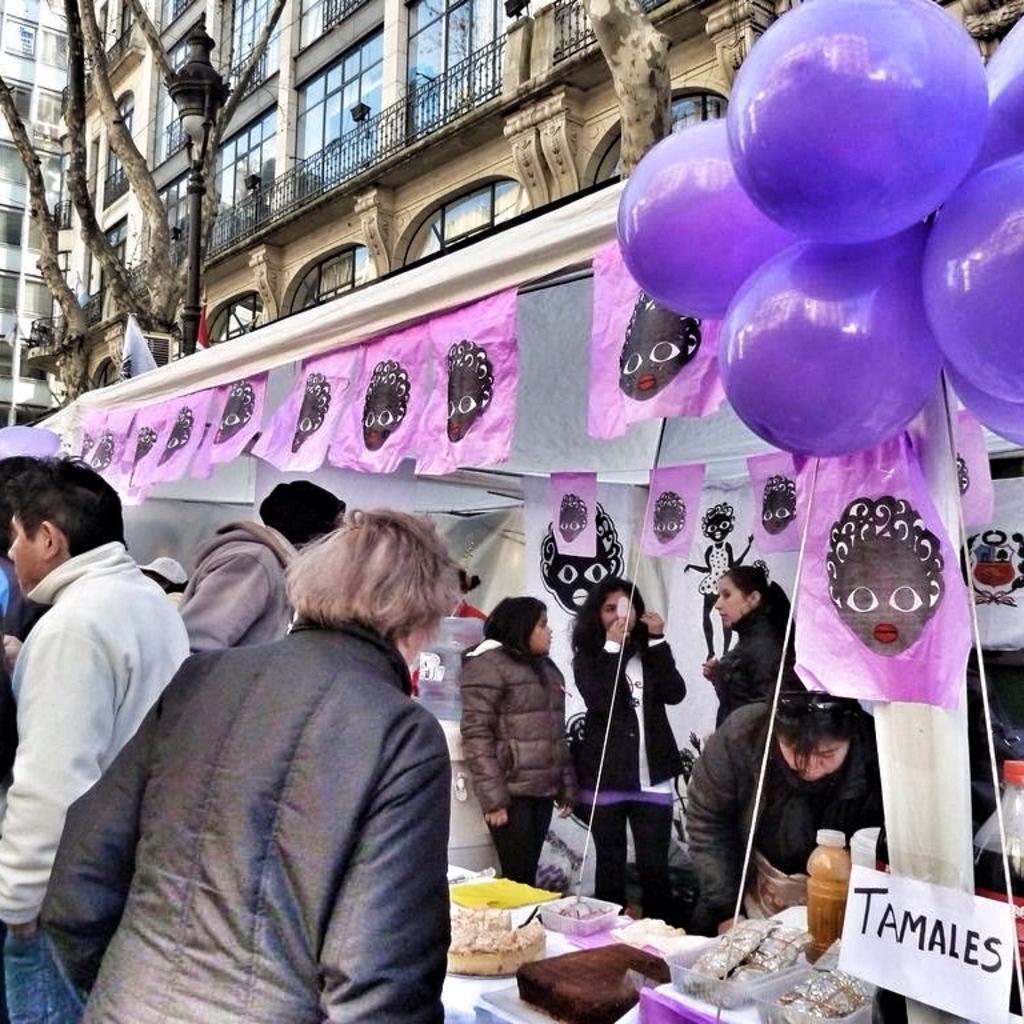How would you summarize this image in a sentence or two? There is a stall on the side of the road and there are some people standing in front of the stall. One woman and two men standing there. Inside the stall there are four women and there are some balloons hanging outside the stall. There is a street light behind the stall. There is a tree in front of a building and in the background there is a building with windows covered with glasses. There is a railing in front of the windows. And there are some food items in the stall which are placed on the table. 